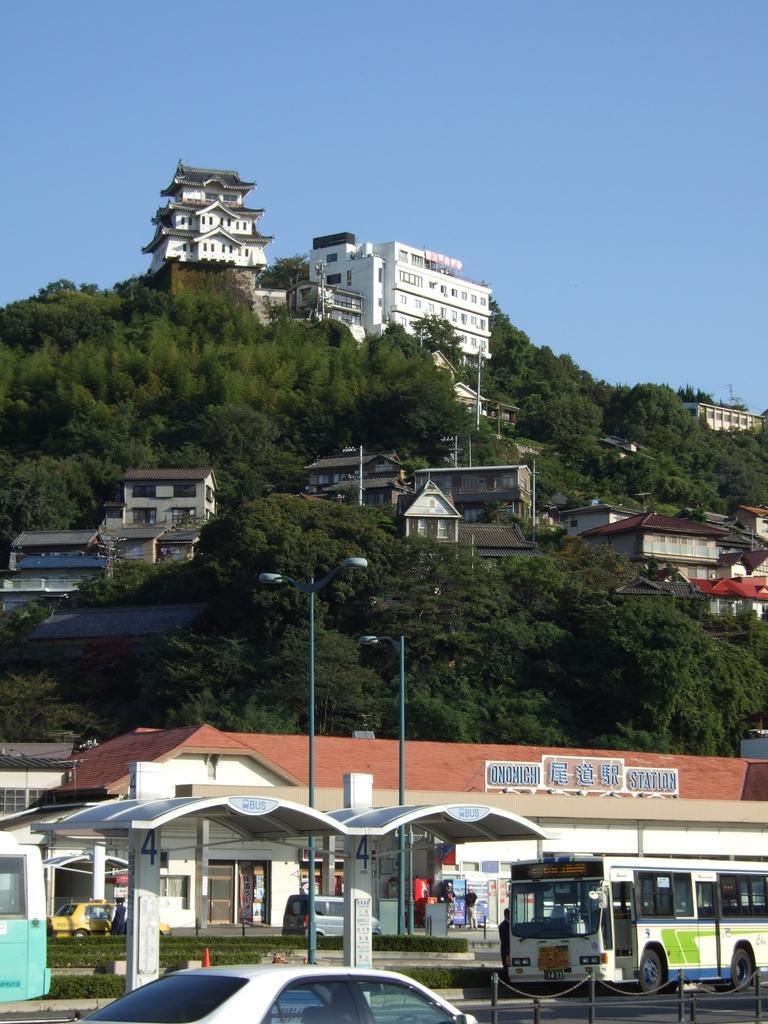In one or two sentences, can you explain what this image depicts? We can see vehicles,lights on poles,shed,grass and buildings. In the background we can see trees,buildings and sky in blue color. 